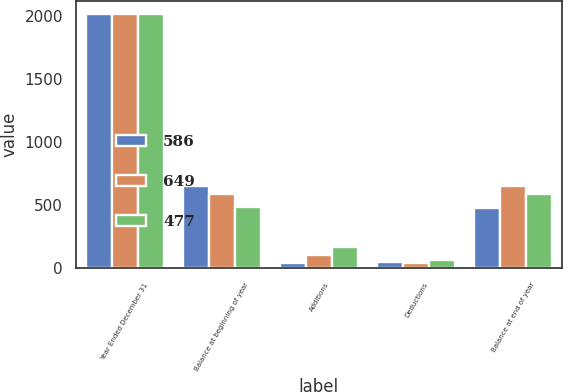<chart> <loc_0><loc_0><loc_500><loc_500><stacked_bar_chart><ecel><fcel>Year Ended December 31<fcel>Balance at beginning of year<fcel>Additions<fcel>Deductions<fcel>Balance at end of year<nl><fcel>586<fcel>2015<fcel>649<fcel>42<fcel>51<fcel>477<nl><fcel>649<fcel>2014<fcel>586<fcel>104<fcel>41<fcel>649<nl><fcel>477<fcel>2013<fcel>487<fcel>169<fcel>70<fcel>586<nl></chart> 